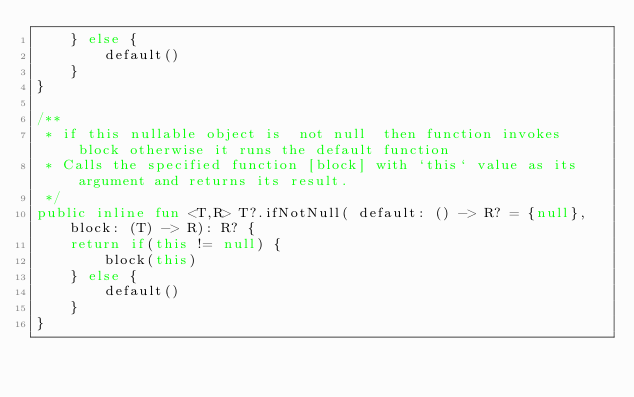<code> <loc_0><loc_0><loc_500><loc_500><_Kotlin_>    } else {
        default()
    }
}

/**
 * if this nullable object is  not null  then function invokes block otherwise it runs the default function
 * Calls the specified function [block] with `this` value as its argument and returns its result.
 */
public inline fun <T,R> T?.ifNotNull( default: () -> R? = {null}, block: (T) -> R): R? {
    return if(this != null) {
        block(this)
    } else {
        default()
    }
}</code> 